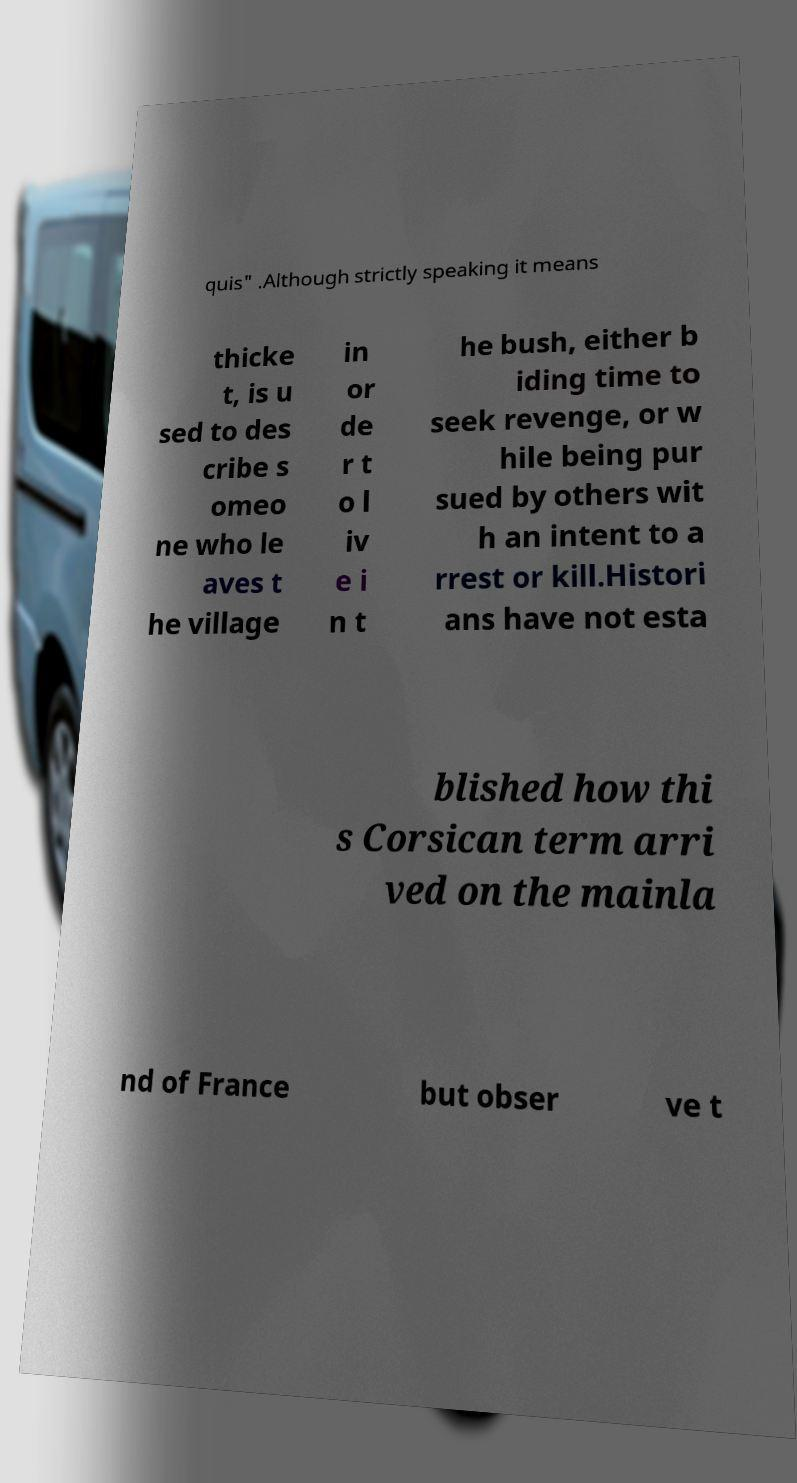Could you extract and type out the text from this image? quis" .Although strictly speaking it means thicke t, is u sed to des cribe s omeo ne who le aves t he village in or de r t o l iv e i n t he bush, either b iding time to seek revenge, or w hile being pur sued by others wit h an intent to a rrest or kill.Histori ans have not esta blished how thi s Corsican term arri ved on the mainla nd of France but obser ve t 